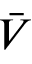<formula> <loc_0><loc_0><loc_500><loc_500>\bar { V }</formula> 